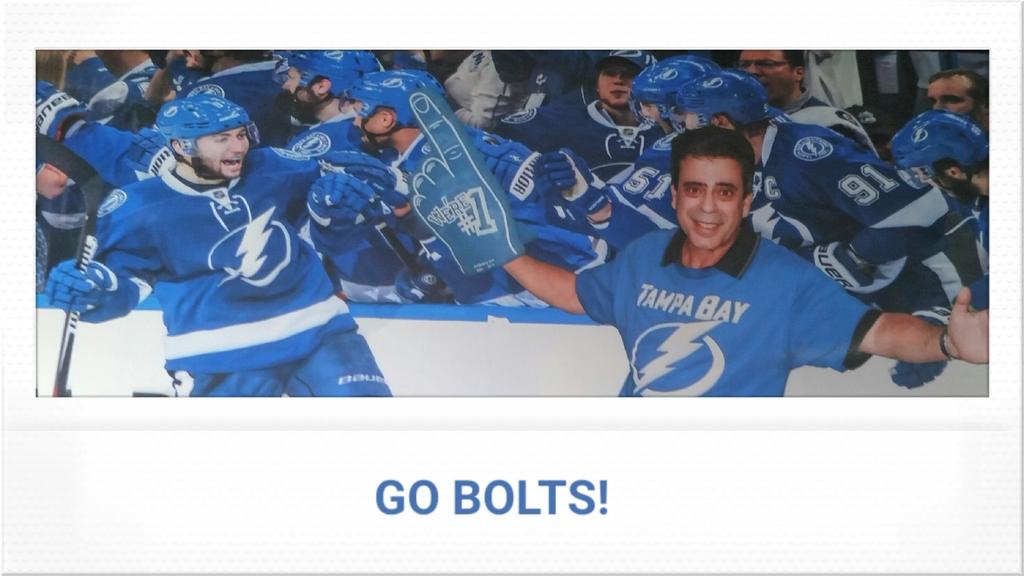Which team does the guy with the foam finger support?
Ensure brevity in your answer.  Tampa bay. What city is on the blue jersey?
Keep it short and to the point. Tampa bay. 